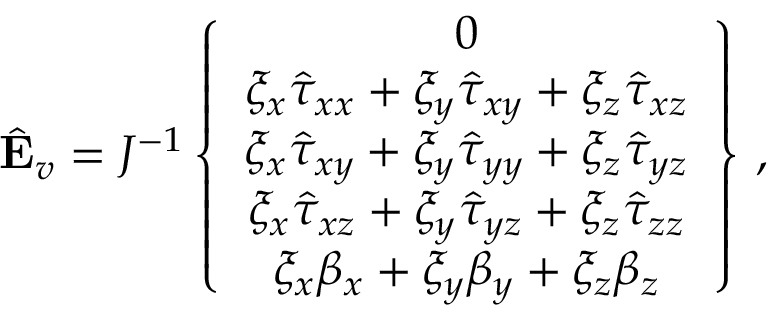<formula> <loc_0><loc_0><loc_500><loc_500>\hat { E } _ { v } = J ^ { - 1 } \left \{ \begin{array} { c } { 0 } \\ { \xi _ { x } \hat { \tau } _ { x x } + \xi _ { y } \hat { \tau } _ { x y } + \xi _ { z } \hat { \tau } _ { x z } } \\ { \xi _ { x } \hat { \tau } _ { x y } + \xi _ { y } \hat { \tau } _ { y y } + \xi _ { z } \hat { \tau } _ { y z } } \\ { \xi _ { x } \hat { \tau } _ { x z } + \xi _ { y } \hat { \tau } _ { y z } + \xi _ { z } \hat { \tau } _ { z z } } \\ { \xi _ { x } { \beta } _ { x } + \xi _ { y } { \beta } _ { y } + \xi _ { z } { \beta } _ { z } } \end{array} \right \} \, ,</formula> 